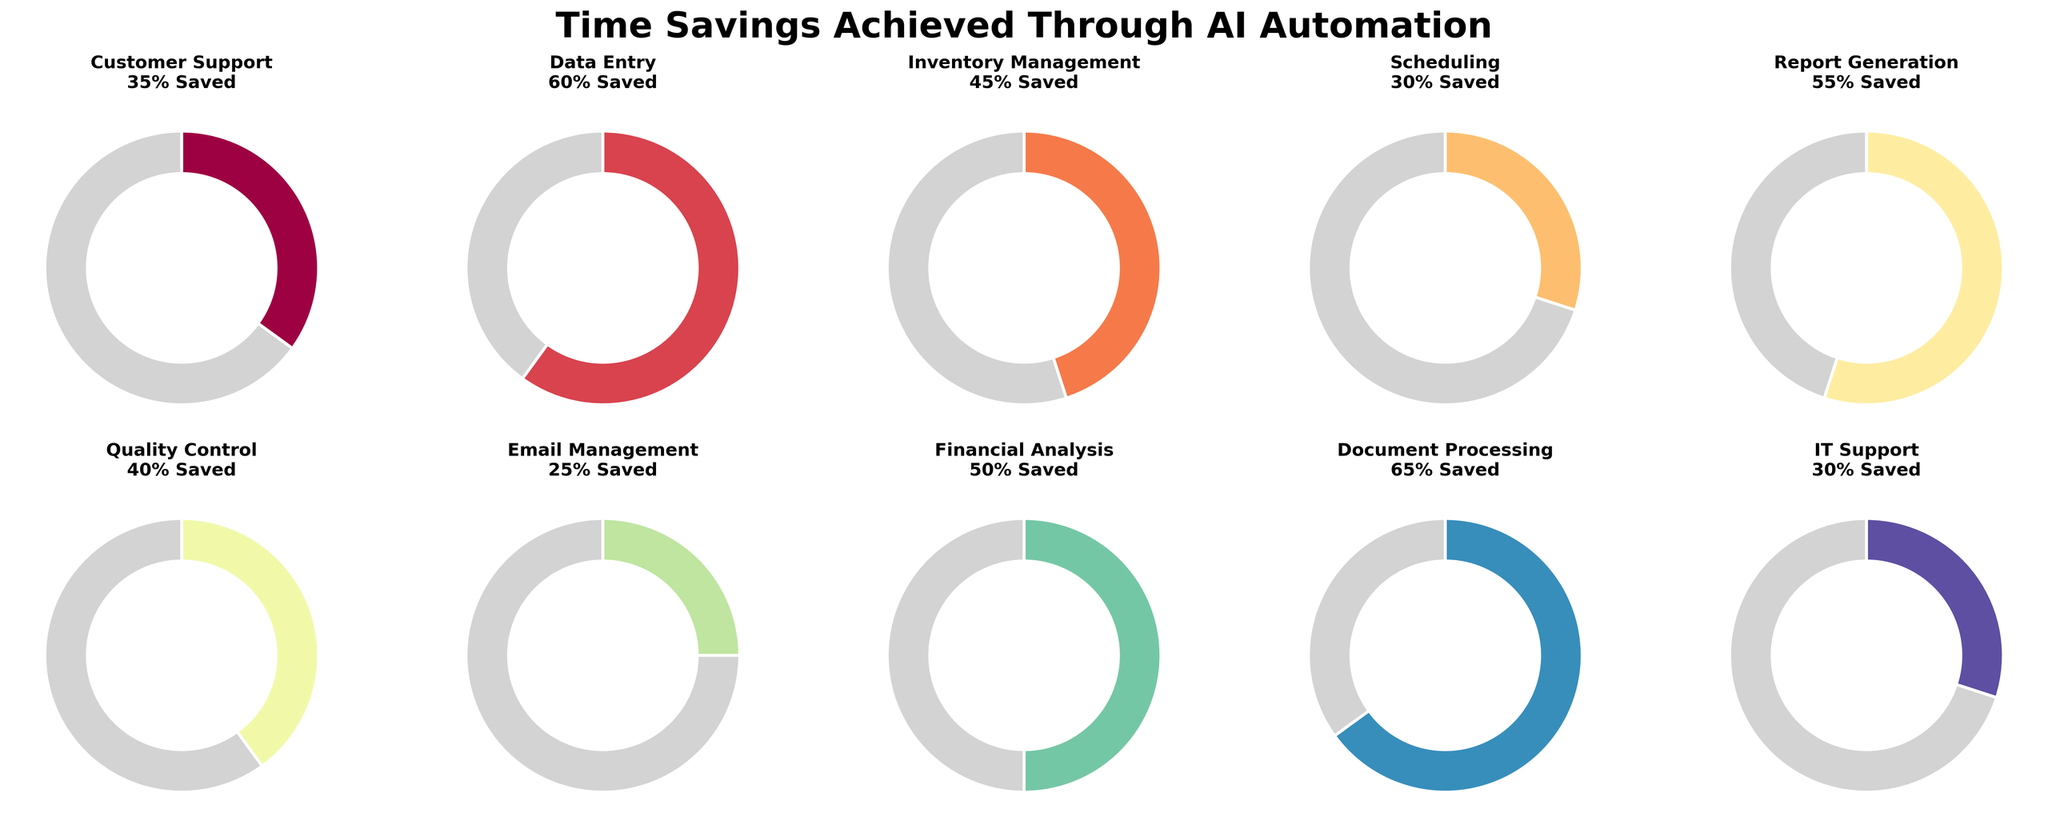What's the title of the subplot? The title is displayed at the top of the figure, and it reads "Time Savings Achieved Through AI Automation".
Answer: Time Savings Achieved Through AI Automation How many business processes are represented in the figure? The subplot consists of 10 pie charts, each representing a different business process. By counting the pie charts, we can determine there are 10 processes.
Answer: 10 Which business process has the highest percentage of time saved due to AI automation? By observing the percentage labels in each pie chart, the highest value among them is "Document Processing," which shows a 65% time saved.
Answer: Document Processing What is the percentage of time saved for Financial Analysis? The number displayed in the pie chart for Financial Analysis is 50%, which represents the time saved.
Answer: 50% Compare the time saved in Customer Support and Report Generation. Which is greater? Customer Support shows 35% time saved, while Report Generation shows 55%. 55% is greater than 35%, so the time saved in Report Generation is greater.
Answer: Report Generation What's the average percentage of time saved across all business processes? To find the average, sum all percentages (35 + 60 + 45 + 30 + 55 + 40 + 25 + 50 + 65 + 30 = 435) and divide by the number of processes (10). So, 435/10 = 43.5%.
Answer: 43.5% How many business processes have less than 40% time saved? By looking at each pie chart, the processes with less than 40% time saved are Customer Support (35%), Scheduling (30%), Email Management (25%), and IT Support (30%). Thus, there are 4 processes.
Answer: 4 Is the time saved in Data Entry more than double the time saved in IT Support? Data Entry shows 60% time saved, and IT Support shows 30%. Double the time saved in IT Support is 30% * 2 = 60%. Since 60% is equal to 60%, they are not more than double.
Answer: No Which business process has the closest percentage of time saved to the overall average? The overall average is 43.5%. Comparing this to the percentages: Customer Support (35%), Data Entry (60%), Inventory Management (45%), Scheduling (30%), Report Generation (55%), Quality Control (40%), Email Management (25%), Financial Analysis (50%), Document Processing (65%), IT Support (30%), Inventory Management at 45% is closest to 43.5%.
Answer: Inventory Management 